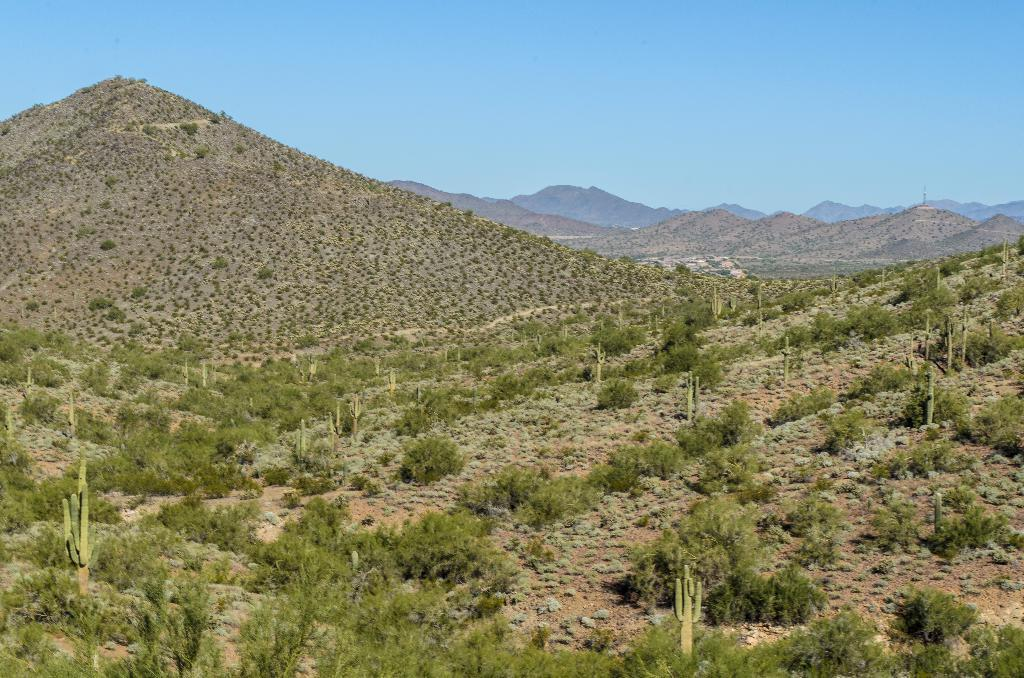What type of natural formation can be seen in the image? There are mountains in the image. What is visible at the top of the image? The sky is visible at the top of the image. What type of vegetation is present at the bottom of the image? There are plants on the ground at the bottom of the image. What type of news can be seen on the mountains in the image? There is no news present in the image; it features mountains, sky, and plants. Can you spot a rabbit among the plants at the bottom of the image? There is no rabbit present in the image; it only features plants. 